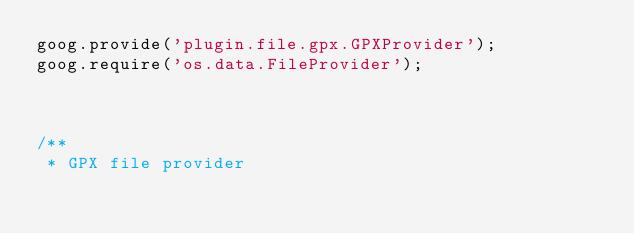Convert code to text. <code><loc_0><loc_0><loc_500><loc_500><_JavaScript_>goog.provide('plugin.file.gpx.GPXProvider');
goog.require('os.data.FileProvider');



/**
 * GPX file provider</code> 